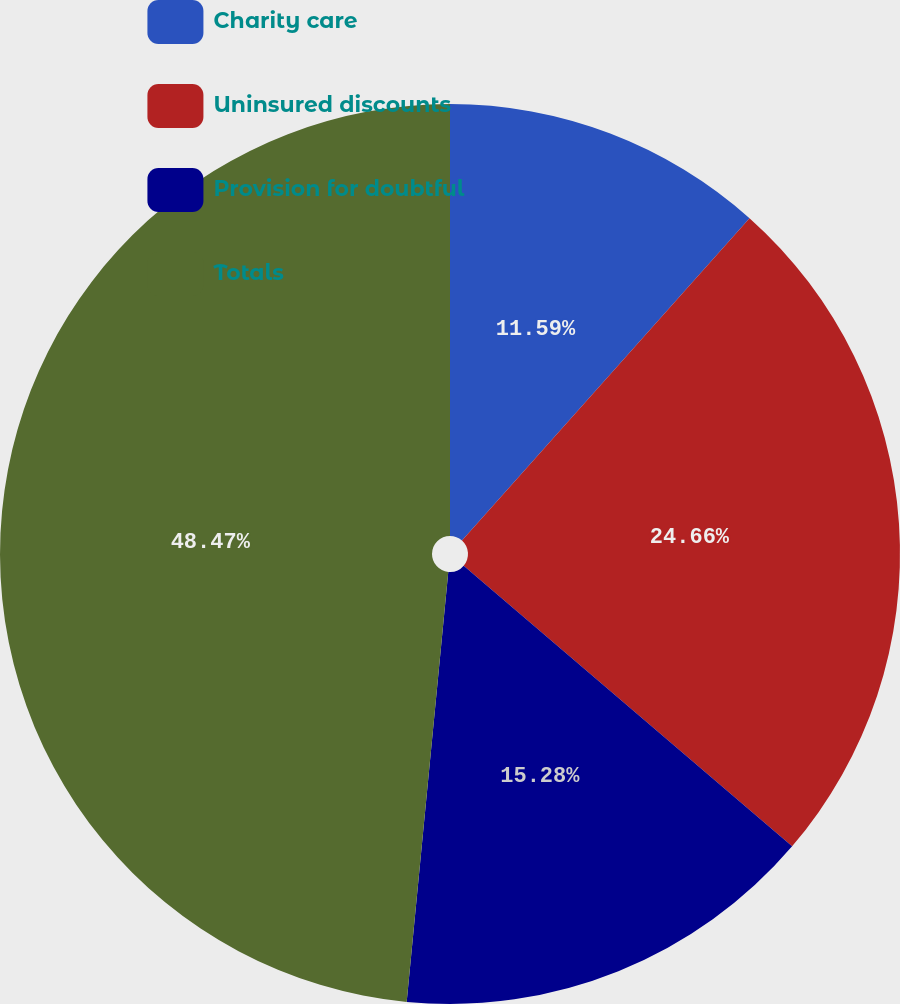Convert chart. <chart><loc_0><loc_0><loc_500><loc_500><pie_chart><fcel>Charity care<fcel>Uninsured discounts<fcel>Provision for doubtful<fcel>Totals<nl><fcel>11.59%<fcel>24.66%<fcel>15.28%<fcel>48.46%<nl></chart> 